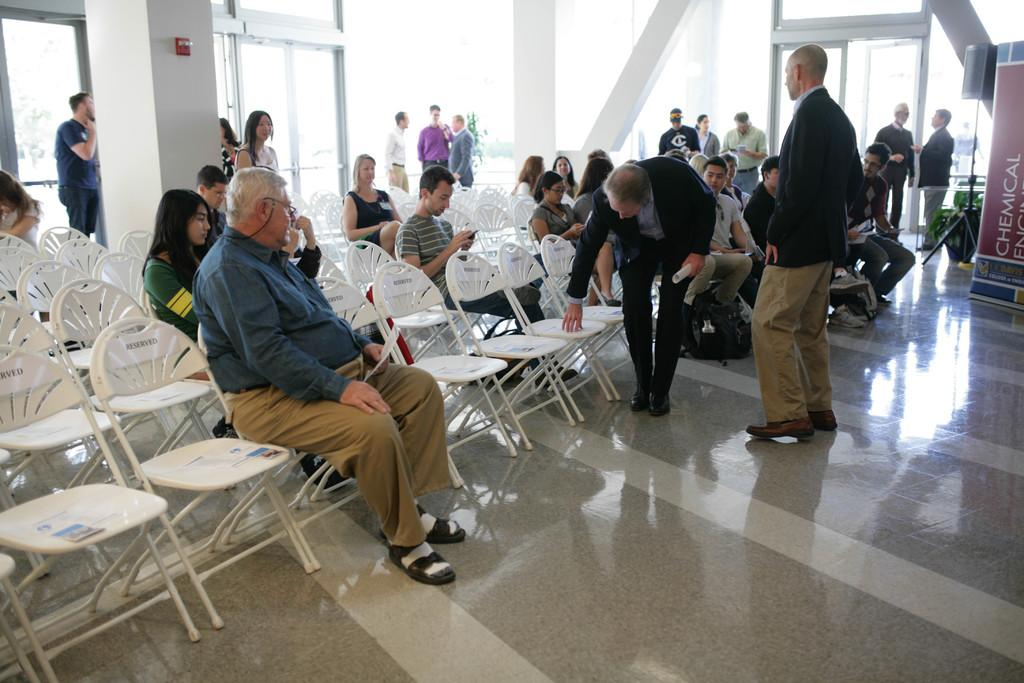What are the people in the image doing? There is a group of people sitting and a group of people standing in the image. What can be seen in the background of the image? There is a hoarding, a speaker, and a door in the background of the image. How many ants can be seen crawling on the coat in the image? There are no ants or coats present in the image. What type of wall is visible in the image? There is no wall visible in the image. 